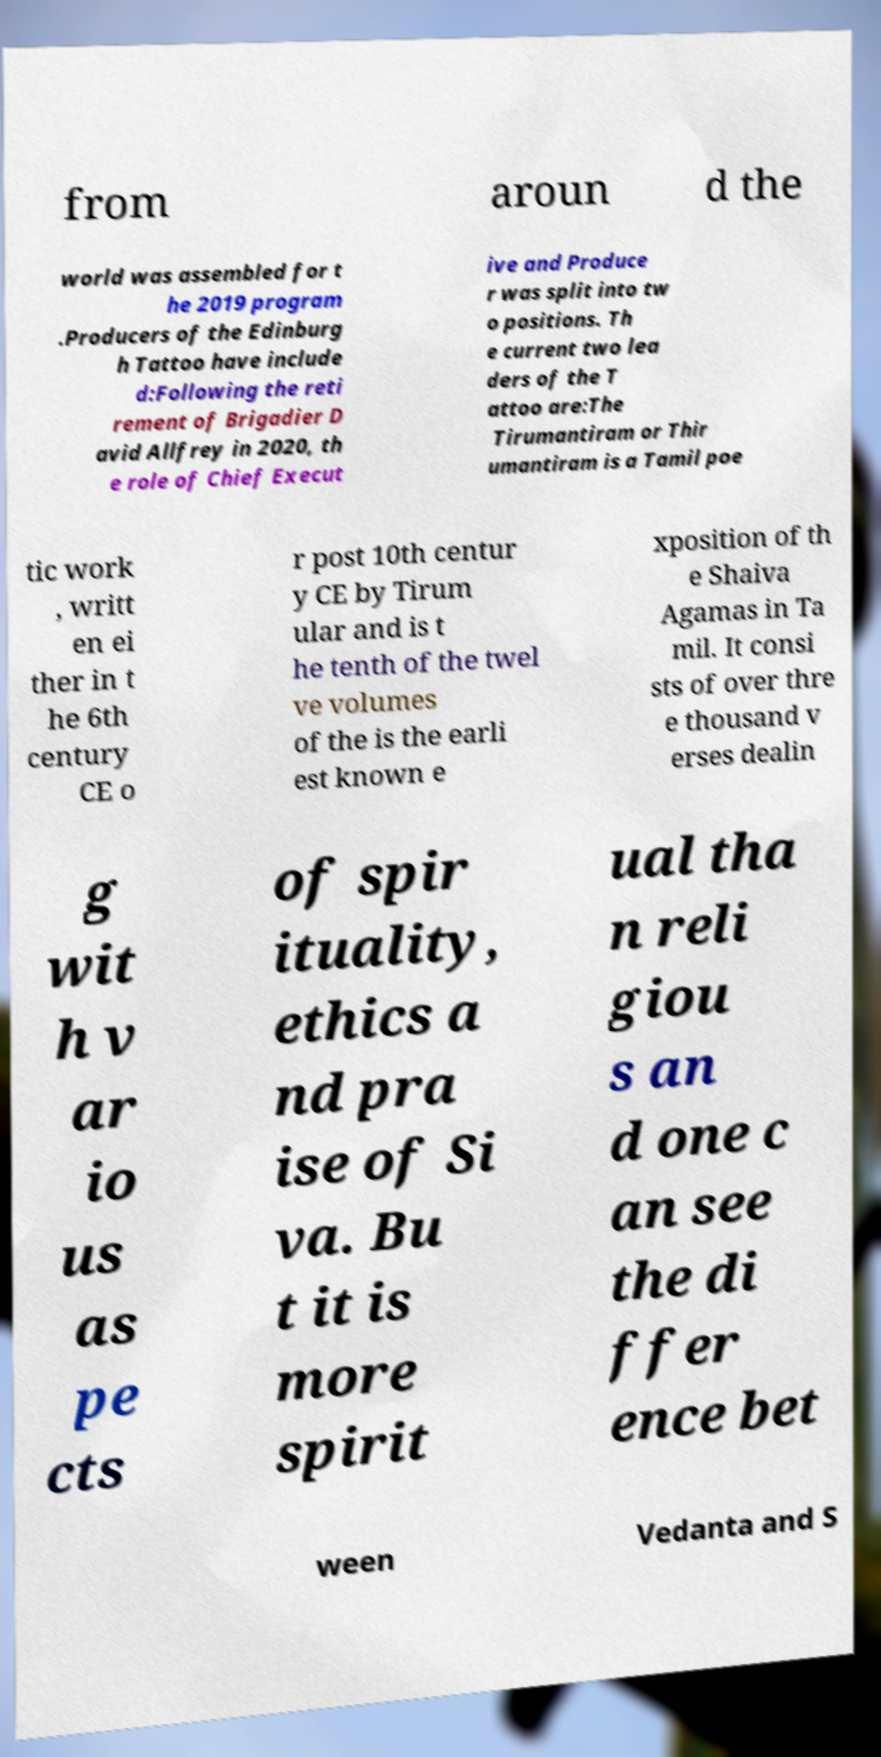There's text embedded in this image that I need extracted. Can you transcribe it verbatim? from aroun d the world was assembled for t he 2019 program .Producers of the Edinburg h Tattoo have include d:Following the reti rement of Brigadier D avid Allfrey in 2020, th e role of Chief Execut ive and Produce r was split into tw o positions. Th e current two lea ders of the T attoo are:The Tirumantiram or Thir umantiram is a Tamil poe tic work , writt en ei ther in t he 6th century CE o r post 10th centur y CE by Tirum ular and is t he tenth of the twel ve volumes of the is the earli est known e xposition of th e Shaiva Agamas in Ta mil. It consi sts of over thre e thousand v erses dealin g wit h v ar io us as pe cts of spir ituality, ethics a nd pra ise of Si va. Bu t it is more spirit ual tha n reli giou s an d one c an see the di ffer ence bet ween Vedanta and S 